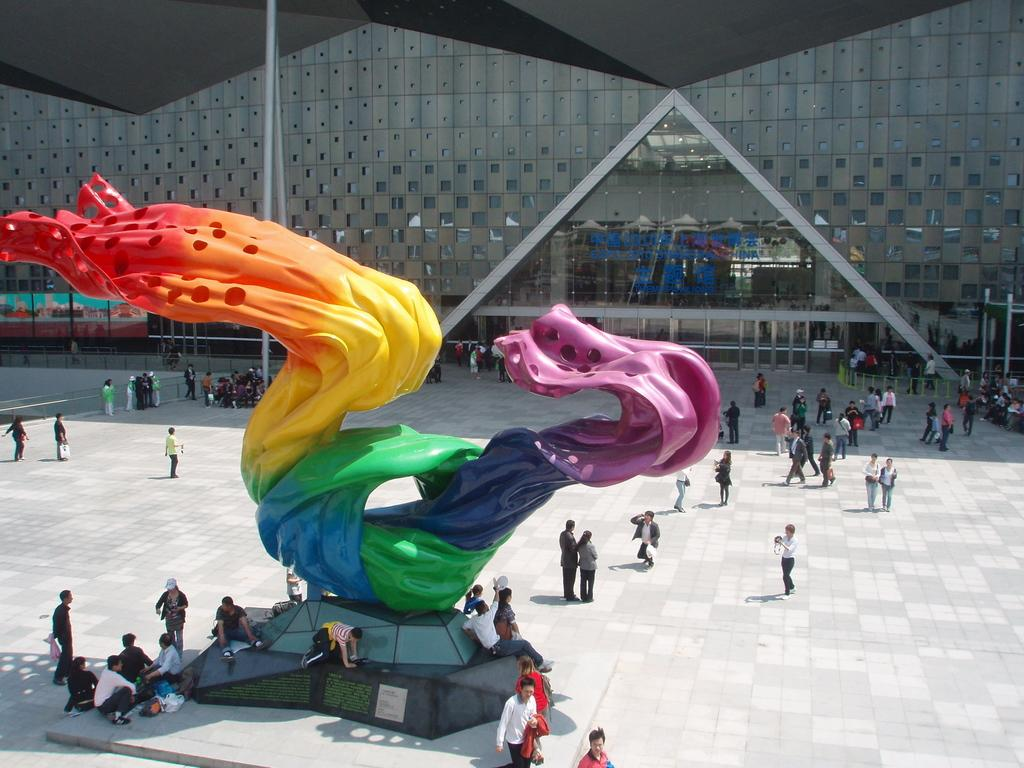How many people are in the image? There is a group of people in the image. What are the people in the image doing? Some people are sitting, while others are standing. What can be seen besides the people in the image? There is a statue in the image. Can you describe the statue? The statue has multiple colors. What is visible in the background of the image? There is a glass window in the background of the image. How many cats are sitting on the statue in the image? There are no cats present in the image; it features a group of people and a statue. What type of sponge is being used to clean the glass window in the image? There is no sponge visible in the image, and the glass window is not being cleaned. 